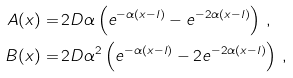Convert formula to latex. <formula><loc_0><loc_0><loc_500><loc_500>A ( x ) = & \, 2 D \alpha \left ( e ^ { - \alpha ( x - l ) } - e ^ { - 2 \alpha ( x - l ) } \right ) \, , \\ B ( x ) = & \, 2 D \alpha ^ { 2 } \left ( e ^ { - \alpha ( x - l ) } - 2 e ^ { - 2 \alpha ( x - l ) } \right ) \, ,</formula> 